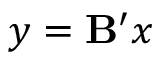Convert formula to latex. <formula><loc_0><loc_0><loc_500><loc_500>y = B ^ { \prime } x</formula> 